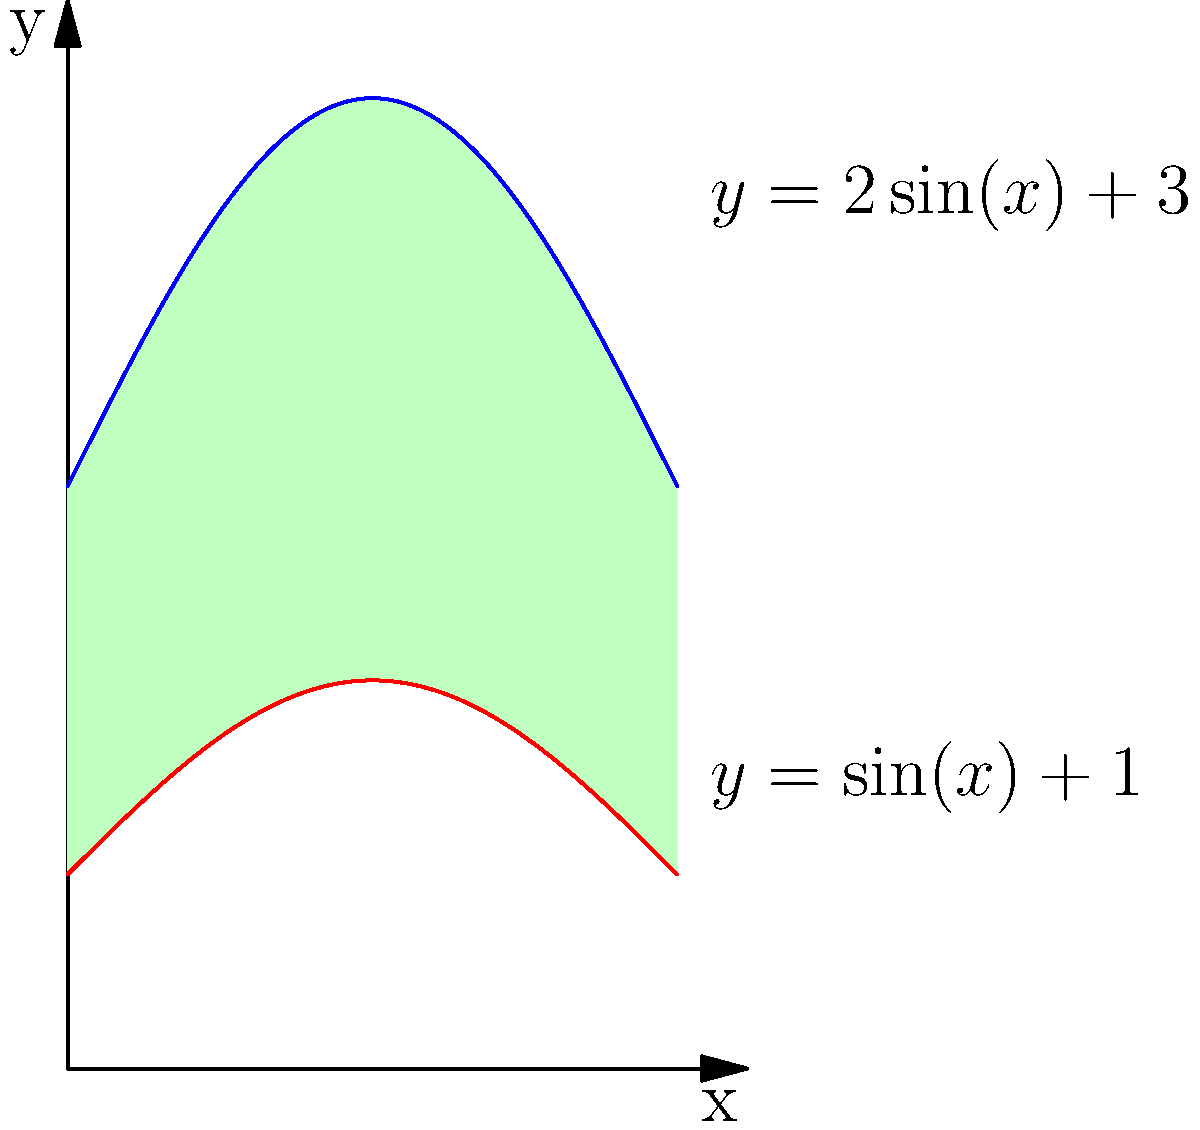As a plein air painter specializing in urban landscapes, you're sketching a uniquely shaped building. The building's profile can be modeled by two functions: $y=2\sin(x)+3$ for the upper curve and $y=\sin(x)+1$ for the lower curve, where $x$ is measured in radians from 0 to $\pi$. Calculate the area of the building's profile using integral calculus. To find the area between two curves, we need to integrate the difference of the functions over the given interval. Let's approach this step-by-step:

1) The area between two curves is given by the formula:
   $$A = \int_a^b [f(x) - g(x)] dx$$
   where $f(x)$ is the upper function and $g(x)$ is the lower function.

2) In this case:
   $f(x) = 2\sin(x) + 3$
   $g(x) = \sin(x) + 1$
   $a = 0$ and $b = \pi$

3) Substituting into the formula:
   $$A = \int_0^\pi [(2\sin(x) + 3) - (\sin(x) + 1)] dx$$

4) Simplify the integrand:
   $$A = \int_0^\pi [\sin(x) + 2] dx$$

5) Integrate:
   $$A = [-\cos(x) + 2x]_0^\pi$$

6) Evaluate the integral:
   $$A = [-\cos(\pi) + 2\pi] - [-\cos(0) + 2(0)]$$
   $$A = [1 + 2\pi] - [1 + 0]$$
   $$A = 2\pi$$

Therefore, the area of the building's profile is $2\pi$ square units.
Answer: $2\pi$ square units 